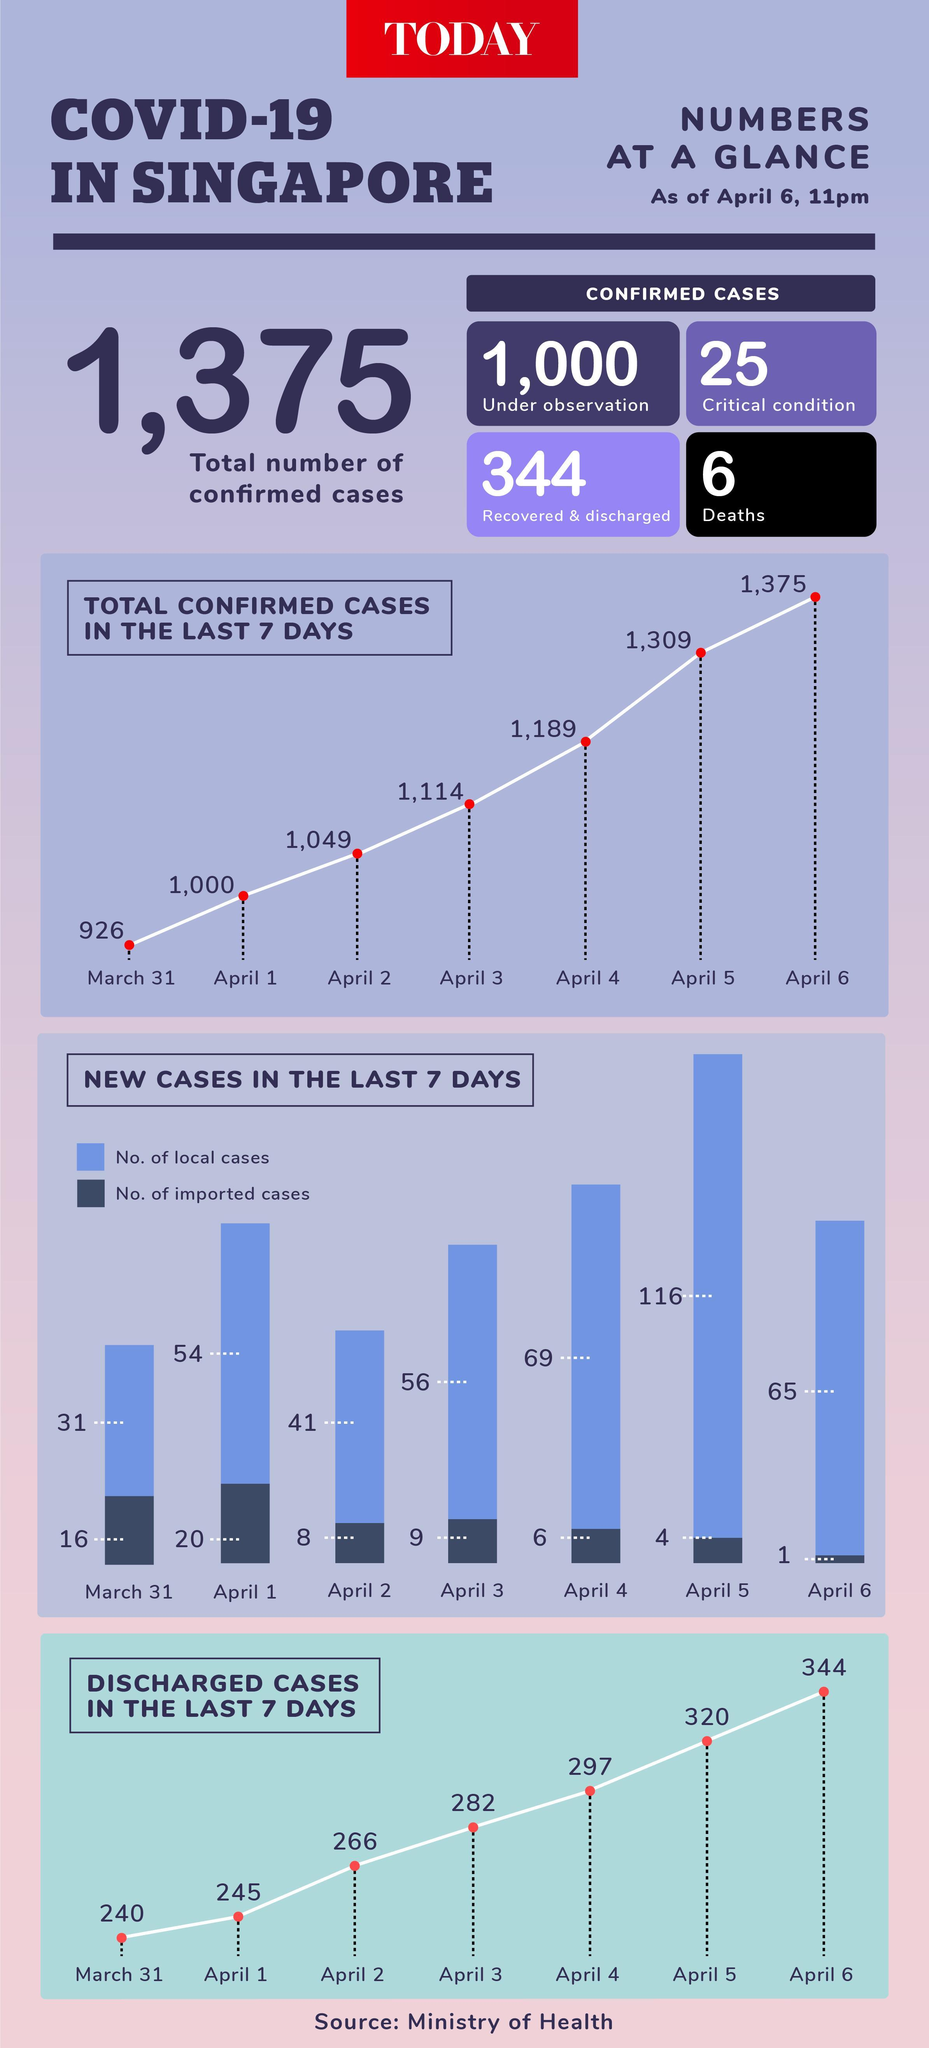Which days had total confirmed cases below 1100?
Answer the question with a short phrase. March 31, April 1, April 2 Among the confirmed Covid cases in Singapore, how many lost their lives? 6 By what number did discharged cases go up from April 1 to April 3? 37 What was the total number of new local and imported cases on April 6? 66 How many imported cases were there on April 3? 9 How many new local cases were reported on April 5? 116 By what number has the total confirmed cases increased from March 31 to April 6? 449 